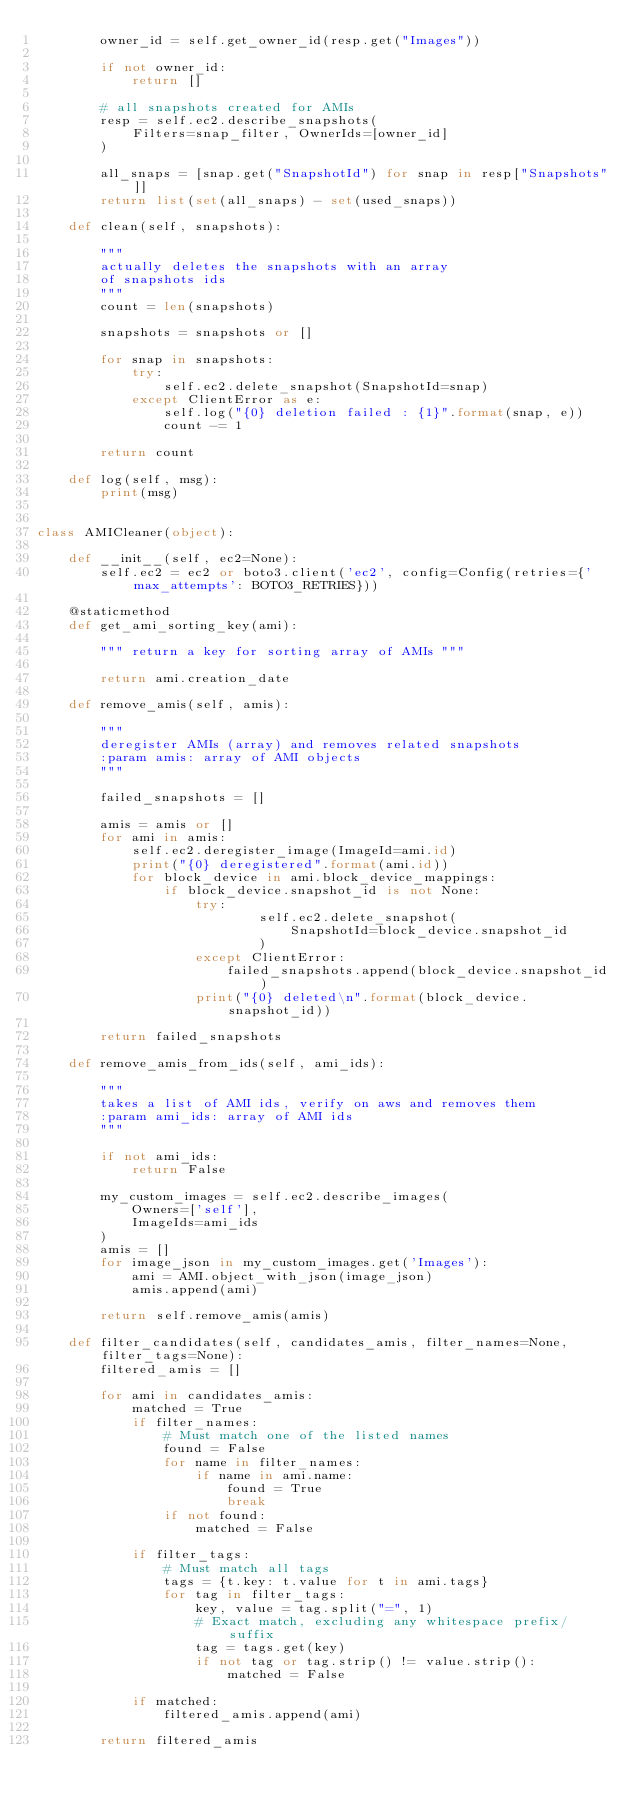Convert code to text. <code><loc_0><loc_0><loc_500><loc_500><_Python_>        owner_id = self.get_owner_id(resp.get("Images"))

        if not owner_id:
            return []

        # all snapshots created for AMIs
        resp = self.ec2.describe_snapshots(
            Filters=snap_filter, OwnerIds=[owner_id]
        )

        all_snaps = [snap.get("SnapshotId") for snap in resp["Snapshots"]]
        return list(set(all_snaps) - set(used_snaps))

    def clean(self, snapshots):

        """
        actually deletes the snapshots with an array
        of snapshots ids
        """
        count = len(snapshots)

        snapshots = snapshots or []

        for snap in snapshots:
            try:
                self.ec2.delete_snapshot(SnapshotId=snap)
            except ClientError as e:
                self.log("{0} deletion failed : {1}".format(snap, e))
                count -= 1

        return count

    def log(self, msg):
        print(msg)


class AMICleaner(object):

    def __init__(self, ec2=None):
        self.ec2 = ec2 or boto3.client('ec2', config=Config(retries={'max_attempts': BOTO3_RETRIES}))

    @staticmethod
    def get_ami_sorting_key(ami):

        """ return a key for sorting array of AMIs """

        return ami.creation_date

    def remove_amis(self, amis):

        """
        deregister AMIs (array) and removes related snapshots
        :param amis: array of AMI objects
        """

        failed_snapshots = []

        amis = amis or []
        for ami in amis:
            self.ec2.deregister_image(ImageId=ami.id)
            print("{0} deregistered".format(ami.id))
            for block_device in ami.block_device_mappings:
                if block_device.snapshot_id is not None:
                    try:
                            self.ec2.delete_snapshot(
                                SnapshotId=block_device.snapshot_id
                            )
                    except ClientError:
                        failed_snapshots.append(block_device.snapshot_id)
                    print("{0} deleted\n".format(block_device.snapshot_id))

        return failed_snapshots

    def remove_amis_from_ids(self, ami_ids):

        """
        takes a list of AMI ids, verify on aws and removes them
        :param ami_ids: array of AMI ids
        """

        if not ami_ids:
            return False

        my_custom_images = self.ec2.describe_images(
            Owners=['self'],
            ImageIds=ami_ids
        )
        amis = []
        for image_json in my_custom_images.get('Images'):
            ami = AMI.object_with_json(image_json)
            amis.append(ami)

        return self.remove_amis(amis)

    def filter_candidates(self, candidates_amis, filter_names=None, filter_tags=None):
        filtered_amis = []

        for ami in candidates_amis:
            matched = True
            if filter_names:
                # Must match one of the listed names
                found = False
                for name in filter_names:
                    if name in ami.name:
                        found = True
                        break
                if not found:
                    matched = False

            if filter_tags:
                # Must match all tags
                tags = {t.key: t.value for t in ami.tags}
                for tag in filter_tags:
                    key, value = tag.split("=", 1)
                    # Exact match, excluding any whitespace prefix/suffix
                    tag = tags.get(key)
                    if not tag or tag.strip() != value.strip():
                        matched = False

            if matched:
                filtered_amis.append(ami)

        return filtered_amis

</code> 